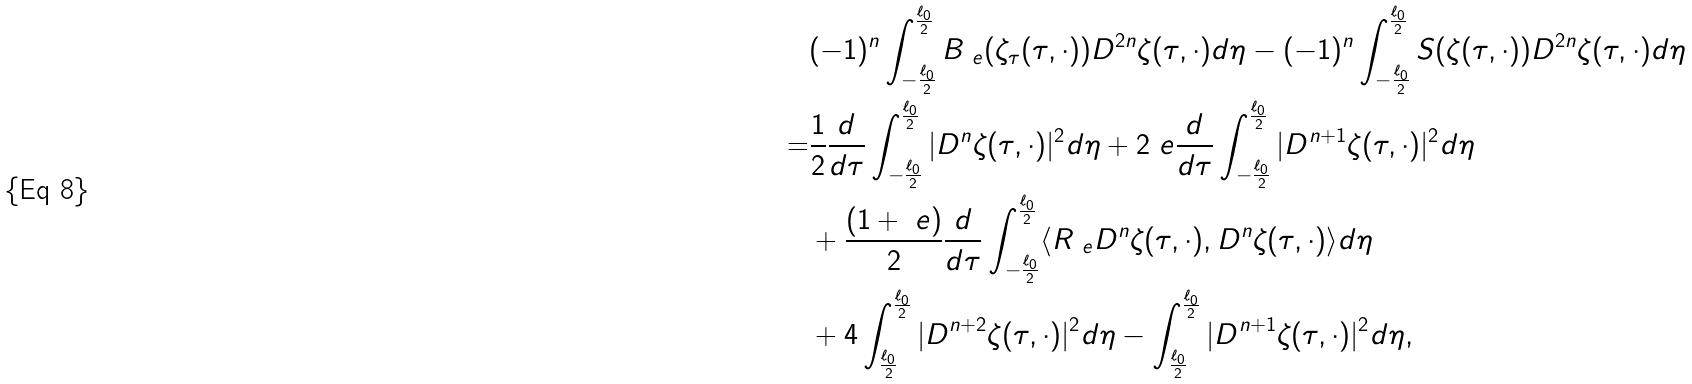Convert formula to latex. <formula><loc_0><loc_0><loc_500><loc_500>& ( - 1 ) ^ { n } \int _ { - \frac { \ell _ { 0 } } { 2 } } ^ { \frac { \ell _ { 0 } } { 2 } } B _ { \ e } ( \zeta _ { \tau } ( \tau , \cdot ) ) D ^ { 2 n } \zeta ( \tau , \cdot ) d \eta - ( - 1 ) ^ { n } \int _ { - \frac { \ell _ { 0 } } { 2 } } ^ { \frac { \ell _ { 0 } } { 2 } } S ( \zeta ( \tau , \cdot ) ) D ^ { 2 n } \zeta ( \tau , \cdot ) d \eta \\ = & \frac { 1 } { 2 } \frac { d } { d \tau } \int _ { - \frac { \ell _ { 0 } } { 2 } } ^ { \frac { \ell _ { 0 } } { 2 } } | D ^ { n } \zeta ( \tau , \cdot ) | ^ { 2 } d \eta + 2 \ e \frac { d } { d \tau } \int _ { - \frac { \ell _ { 0 } } { 2 } } ^ { \frac { \ell _ { 0 } } { 2 } } | D ^ { n + 1 } \zeta ( \tau , \cdot ) | ^ { 2 } d \eta \\ & + \frac { ( 1 + \ e ) } { 2 } \frac { d } { d \tau } \int _ { - \frac { \ell _ { 0 } } { 2 } } ^ { \frac { \ell _ { 0 } } { 2 } } \langle R _ { \ e } D ^ { n } \zeta ( \tau , \cdot ) , D ^ { n } \zeta ( \tau , \cdot ) \rangle d \eta \\ & + 4 \int _ { \frac { \ell _ { 0 } } { 2 } } ^ { \frac { \ell _ { 0 } } { 2 } } | D ^ { n + 2 } \zeta ( \tau , \cdot ) | ^ { 2 } d \eta - \int _ { \frac { \ell _ { 0 } } { 2 } } ^ { \frac { \ell _ { 0 } } { 2 } } | D ^ { n + 1 } \zeta ( \tau , \cdot ) | ^ { 2 } d \eta ,</formula> 